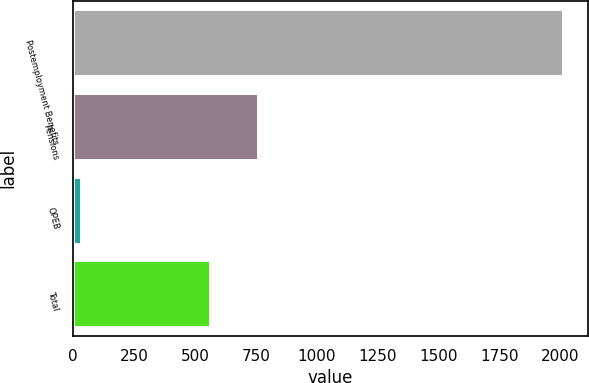Convert chart to OTSL. <chart><loc_0><loc_0><loc_500><loc_500><bar_chart><fcel>Postemployment Benefits<fcel>Pensions<fcel>OPEB<fcel>Total<nl><fcel>2012<fcel>759.8<fcel>34<fcel>562<nl></chart> 